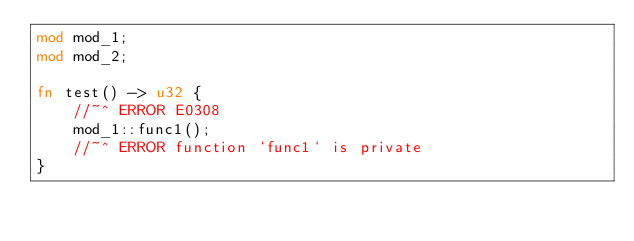Convert code to text. <code><loc_0><loc_0><loc_500><loc_500><_Rust_>mod mod_1;
mod mod_2;

fn test() -> u32 {
    //~^ ERROR E0308
    mod_1::func1();
    //~^ ERROR function `func1` is private
}
</code> 